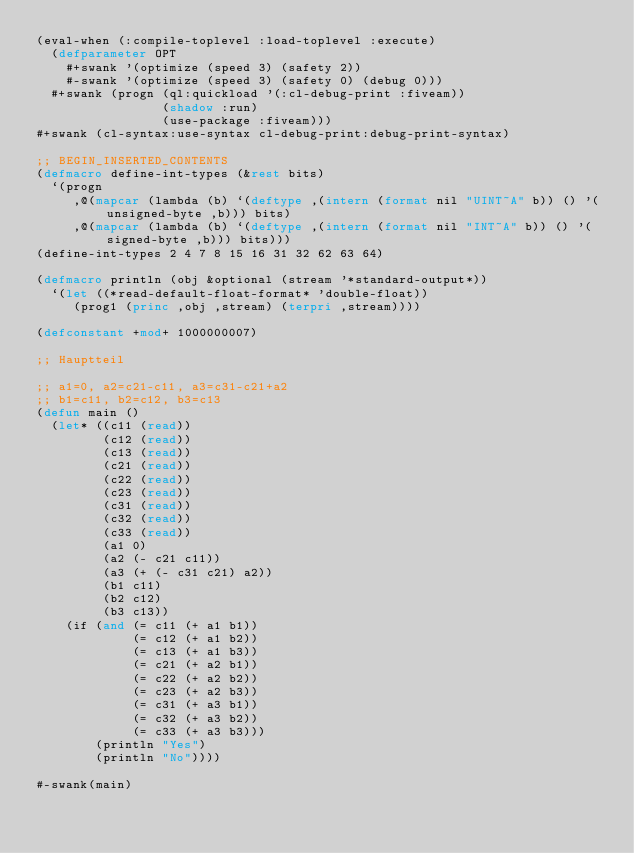<code> <loc_0><loc_0><loc_500><loc_500><_Lisp_>(eval-when (:compile-toplevel :load-toplevel :execute)
  (defparameter OPT
    #+swank '(optimize (speed 3) (safety 2))
    #-swank '(optimize (speed 3) (safety 0) (debug 0)))
  #+swank (progn (ql:quickload '(:cl-debug-print :fiveam))
                 (shadow :run)
                 (use-package :fiveam)))
#+swank (cl-syntax:use-syntax cl-debug-print:debug-print-syntax)

;; BEGIN_INSERTED_CONTENTS
(defmacro define-int-types (&rest bits)
  `(progn
     ,@(mapcar (lambda (b) `(deftype ,(intern (format nil "UINT~A" b)) () '(unsigned-byte ,b))) bits)
     ,@(mapcar (lambda (b) `(deftype ,(intern (format nil "INT~A" b)) () '(signed-byte ,b))) bits)))
(define-int-types 2 4 7 8 15 16 31 32 62 63 64)

(defmacro println (obj &optional (stream '*standard-output*))
  `(let ((*read-default-float-format* 'double-float))
     (prog1 (princ ,obj ,stream) (terpri ,stream))))

(defconstant +mod+ 1000000007)

;; Hauptteil

;; a1=0, a2=c21-c11, a3=c31-c21+a2
;; b1=c11, b2=c12, b3=c13
(defun main ()
  (let* ((c11 (read))
         (c12 (read))
         (c13 (read))
         (c21 (read))
         (c22 (read))
         (c23 (read))
         (c31 (read))
         (c32 (read))
         (c33 (read))
         (a1 0)
         (a2 (- c21 c11))
         (a3 (+ (- c31 c21) a2))
         (b1 c11)
         (b2 c12)
         (b3 c13))
    (if (and (= c11 (+ a1 b1))
             (= c12 (+ a1 b2))
             (= c13 (+ a1 b3))
             (= c21 (+ a2 b1))
             (= c22 (+ a2 b2))
             (= c23 (+ a2 b3))
             (= c31 (+ a3 b1))
             (= c32 (+ a3 b2))
             (= c33 (+ a3 b3)))
        (println "Yes")
        (println "No"))))

#-swank(main)
</code> 